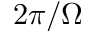Convert formula to latex. <formula><loc_0><loc_0><loc_500><loc_500>2 \pi / \Omega</formula> 